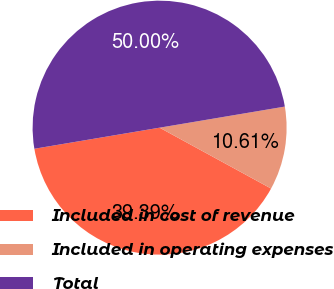Convert chart. <chart><loc_0><loc_0><loc_500><loc_500><pie_chart><fcel>Included in cost of revenue<fcel>Included in operating expenses<fcel>Total<nl><fcel>39.39%<fcel>10.61%<fcel>50.0%<nl></chart> 